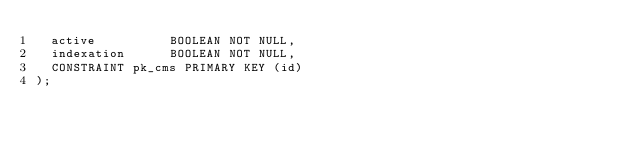<code> <loc_0><loc_0><loc_500><loc_500><_SQL_>  active          BOOLEAN NOT NULL,
  indexation      BOOLEAN NOT NULL,
  CONSTRAINT pk_cms PRIMARY KEY (id)
);</code> 